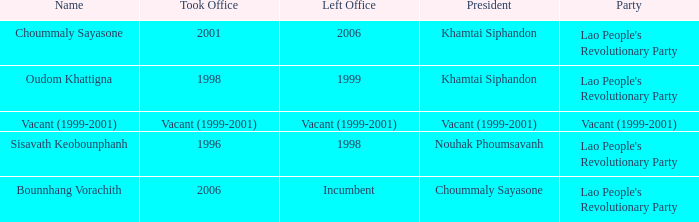What is Left Office, when Took Office is 2006? Incumbent. 